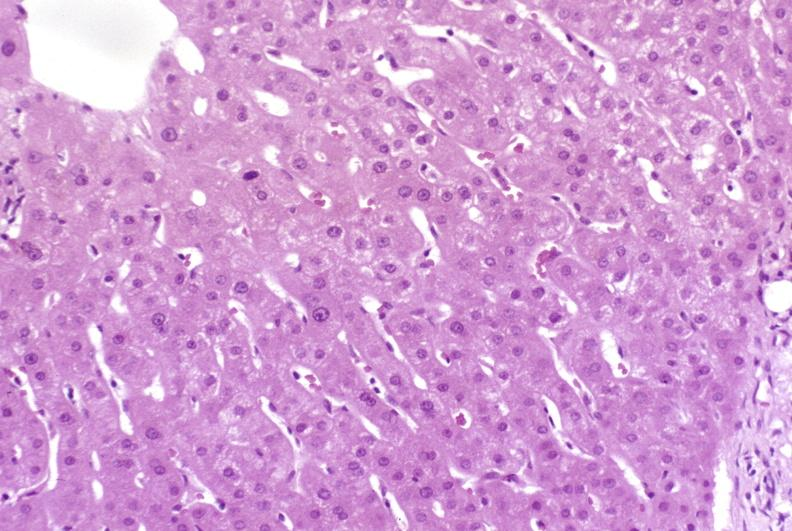does yo show resolving acute rejection?
Answer the question using a single word or phrase. No 